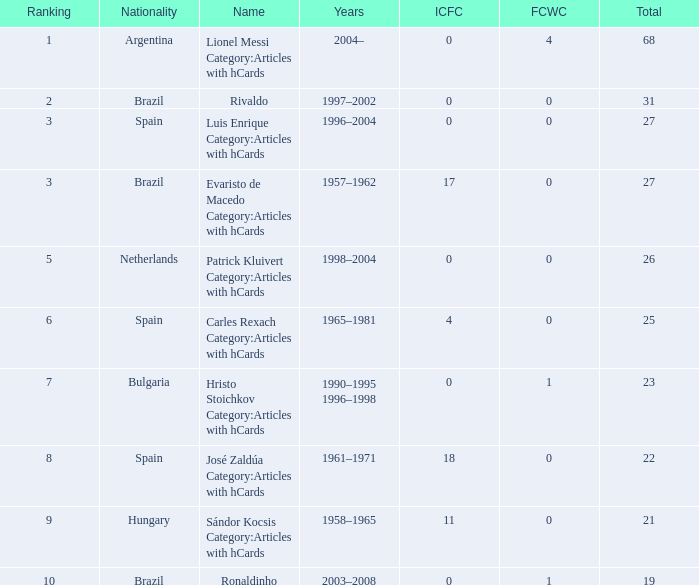What is the highest number of FCWC in the Years of 1958–1965, and an ICFC smaller than 11? None. 